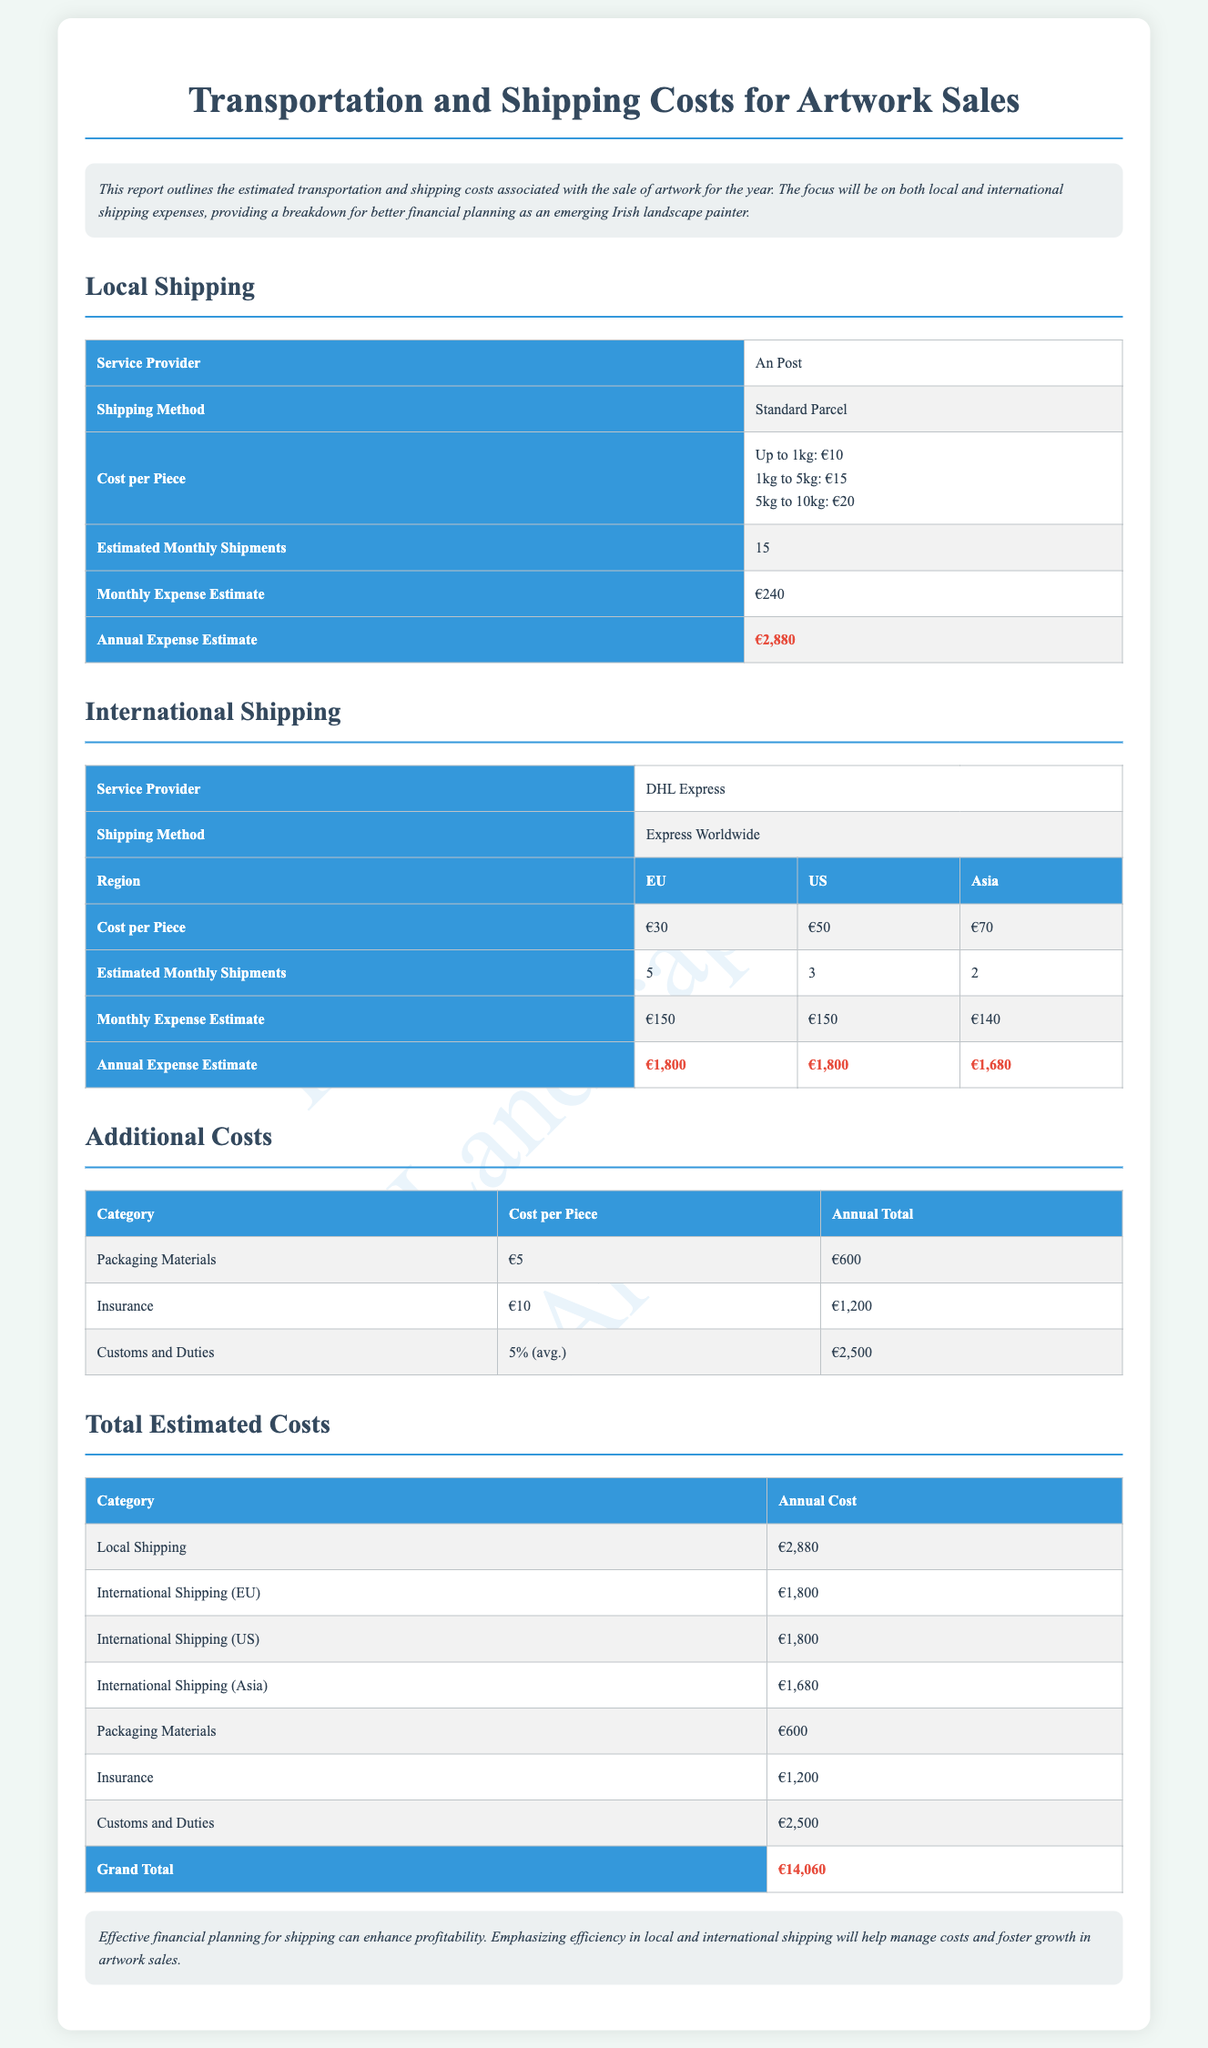What is the annual expense estimate for local shipping? The annual expense estimate for local shipping is clearly stated in the local shipping section, which shows €2,880.
Answer: €2,880 How many estimated monthly shipments are there for international shipping to the US? The estimated monthly shipments for international shipping to the US can be found in the international shipping section, which lists 3 shipments.
Answer: 3 What is the cost per piece for international shipping to Asia? The cost per piece for international shipping to Asia is detailed in the international shipping table and is €70.
Answer: €70 What is the total annual cost for packaging materials? The total annual cost for packaging materials is listed in the additional costs table, indicating €600.
Answer: €600 What is the monthly expense estimate for international shipping to the EU? The monthly expense estimate for international shipping to the EU is provided in the international shipping table as €150.
Answer: €150 What is the grand total of all estimated costs? The grand total of all estimated costs is summarized at the end of the document, which states €14,060.
Answer: €14,060 How much does insurance cost annually? The annual cost for insurance is mentioned in the additional costs table as €1,200.
Answer: €1,200 Which service provider is used for local shipping? The service provider for local shipping is identified in the local shipping section as An Post.
Answer: An Post 